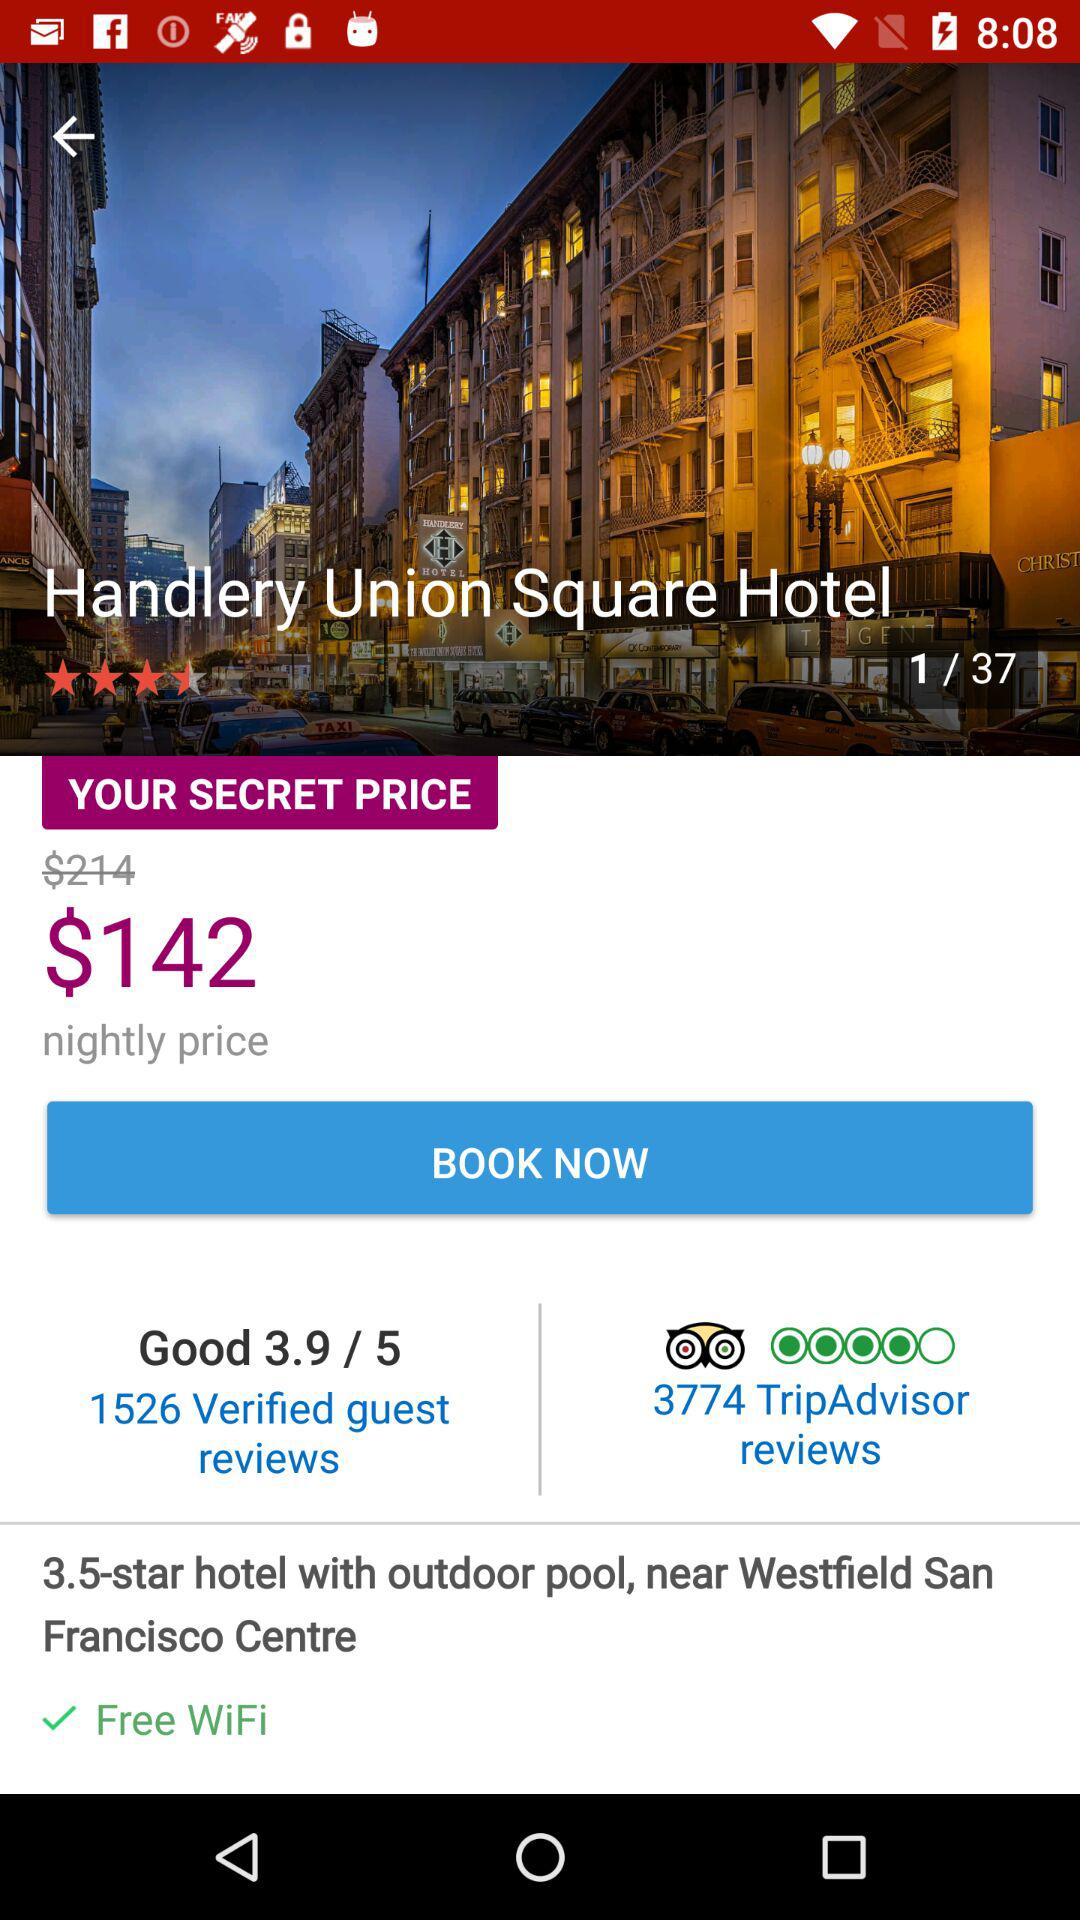How many guest reviews are there for the hotel? There are 1526 guest reviews for the hotel. 